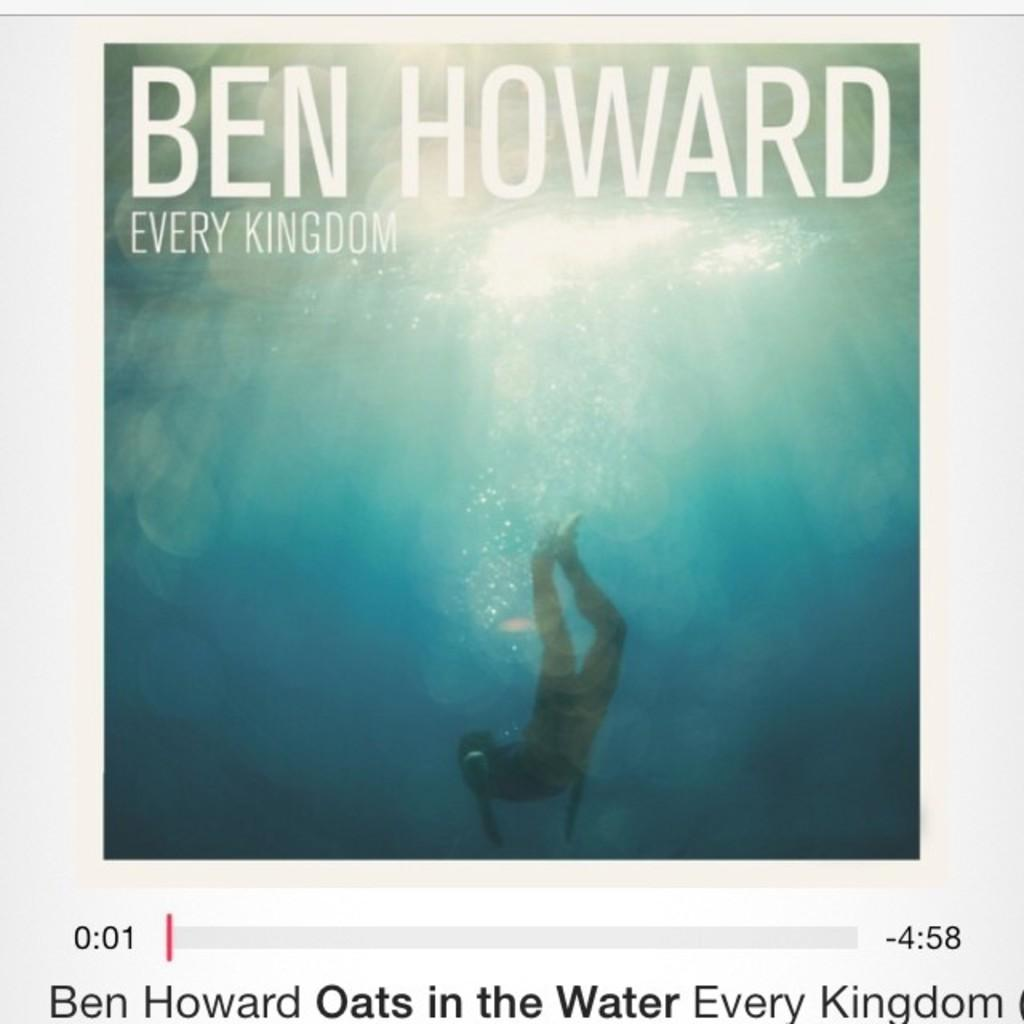<image>
Provide a brief description of the given image. A screen shot of a video of Ben Howard's Every Kingdom. 